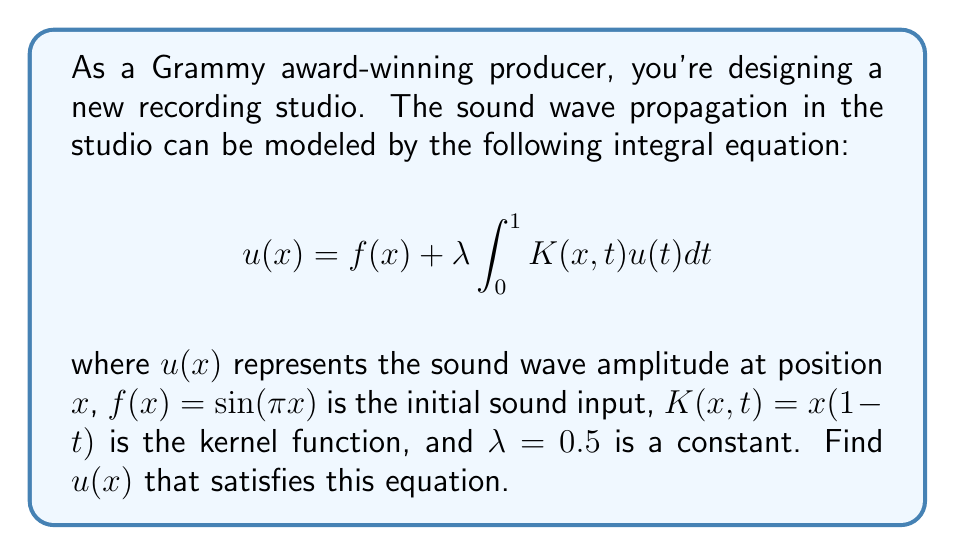What is the answer to this math problem? To solve this integral equation, we'll use the method of successive approximations:

1) Start with the initial approximation $u_0(x) = f(x) = \sin(\pi x)$

2) Use the recurrence relation:
   $$u_{n+1}(x) = f(x) + \lambda \int_0^1 K(x,t)u_n(t)dt$$

3) For the first iteration:
   $$u_1(x) = \sin(\pi x) + 0.5 \int_0^1 x(1-t)\sin(\pi t)dt$$

4) Evaluate the integral:
   $$\int_0^1 (1-t)\sin(\pi t)dt = \frac{1}{\pi} - \frac{2}{\pi^2}$$

5) Substitute back:
   $$u_1(x) = \sin(\pi x) + 0.5x(\frac{1}{\pi} - \frac{2}{\pi^2})$$

6) For the second iteration:
   $$u_2(x) = \sin(\pi x) + 0.5 \int_0^1 x(1-t)[\sin(\pi t) + 0.5t(\frac{1}{\pi} - \frac{2}{\pi^2})]dt$$

7) Evaluate this integral:
   $$\int_0^1 (1-t)[\sin(\pi t) + 0.5t(\frac{1}{\pi} - \frac{2}{\pi^2})]dt = \frac{1}{\pi} - \frac{2}{\pi^2} + \frac{1}{12}(\frac{1}{\pi} - \frac{2}{\pi^2})$$

8) Substitute back:
   $$u_2(x) = \sin(\pi x) + 0.5x[(\frac{1}{\pi} - \frac{2}{\pi^2}) + \frac{1}{12}(\frac{1}{\pi} - \frac{2}{\pi^2})]$$

9) Continuing this process, we find that the solution converges to:
   $$u(x) = \sin(\pi x) + \frac{x}{2-\frac{1}{6}}(\frac{1}{\pi} - \frac{2}{\pi^2})$$
Answer: $u(x) = \sin(\pi x) + \frac{6x}{11}(\frac{1}{\pi} - \frac{2}{\pi^2})$ 